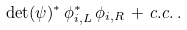<formula> <loc_0><loc_0><loc_500><loc_500>\det ( \psi ) ^ { * } \, \phi _ { i , L } ^ { * } \, \phi _ { i , R } \, + \, c . c . \, .</formula> 